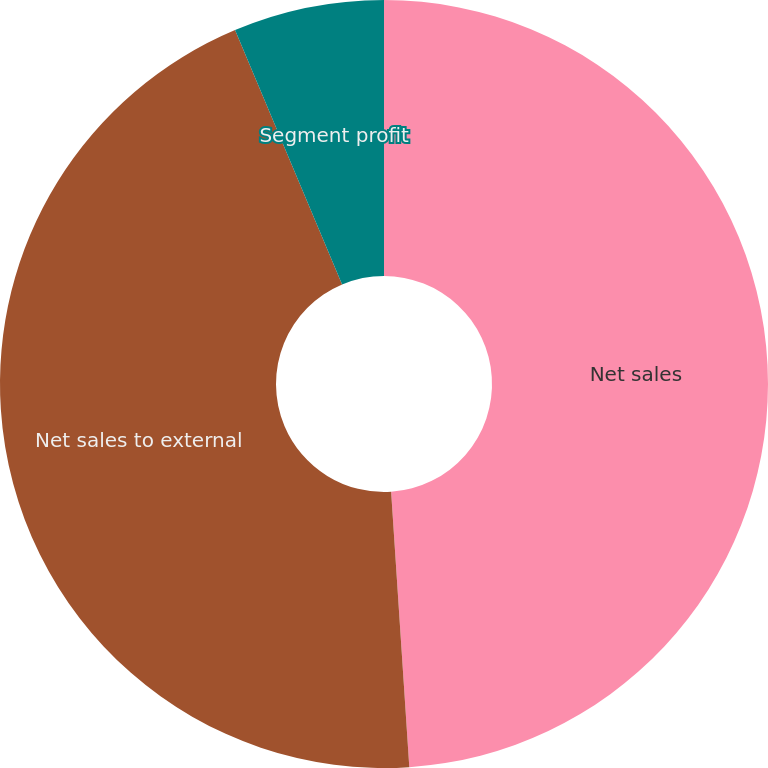<chart> <loc_0><loc_0><loc_500><loc_500><pie_chart><fcel>Net sales<fcel>Net sales to external<fcel>Segment profit<nl><fcel>48.95%<fcel>44.71%<fcel>6.34%<nl></chart> 